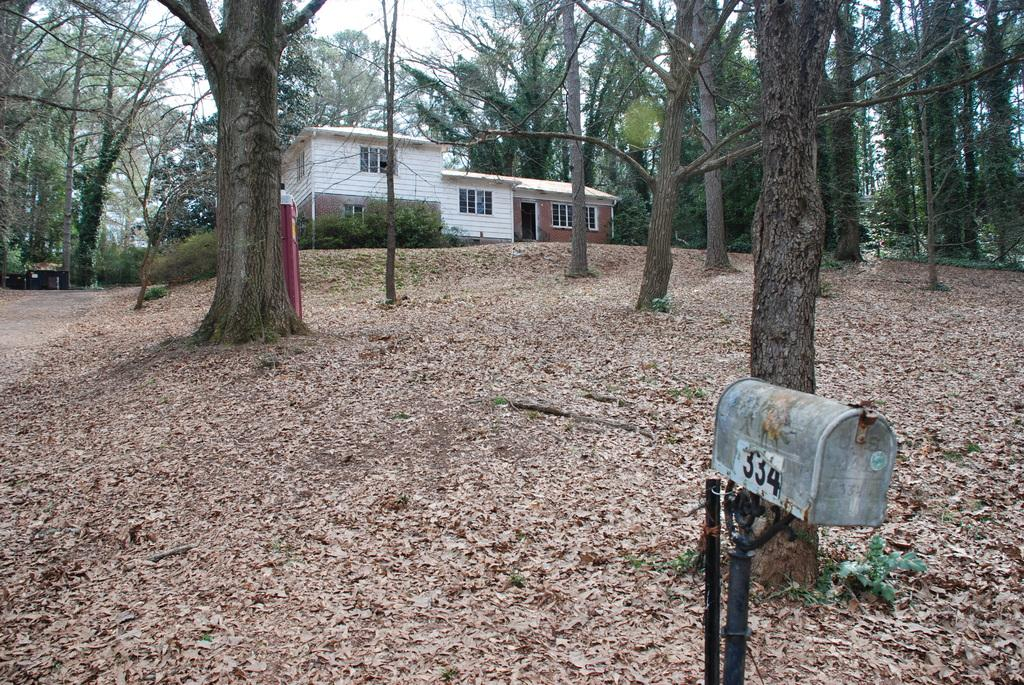What object is the main focus of the image? There is a mailbox in the image. Are there any specific details on the mailbox? Yes, there are numbers written on the mailbox. What can be seen in the background of the image? There are trees and a white-colored house in the background of the image. Can you see anyone touching the rifle in the image? There is no rifle present in the image. What type of stick is leaning against the mailbox in the image? There is no stick leaning against the mailbox in the image. 